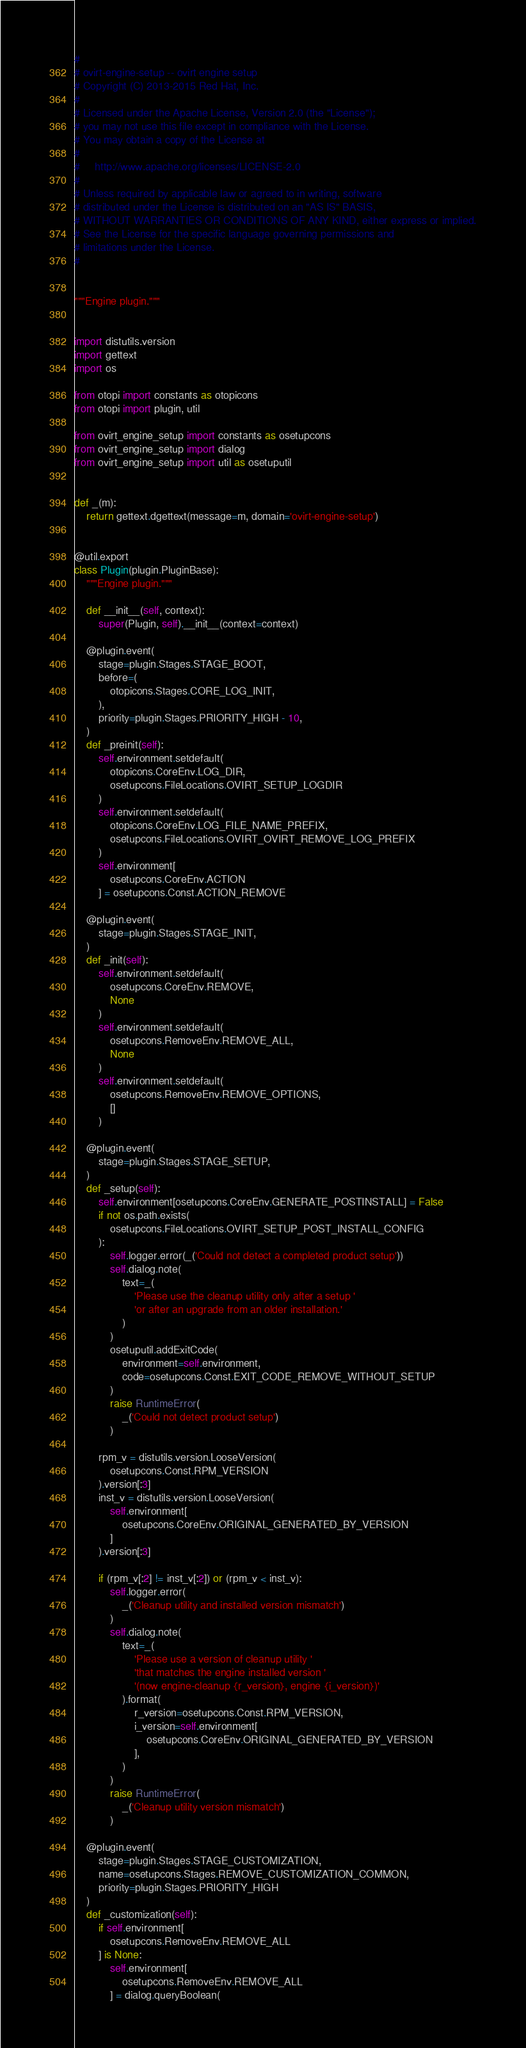Convert code to text. <code><loc_0><loc_0><loc_500><loc_500><_Python_>#
# ovirt-engine-setup -- ovirt engine setup
# Copyright (C) 2013-2015 Red Hat, Inc.
#
# Licensed under the Apache License, Version 2.0 (the "License");
# you may not use this file except in compliance with the License.
# You may obtain a copy of the License at
#
#     http://www.apache.org/licenses/LICENSE-2.0
#
# Unless required by applicable law or agreed to in writing, software
# distributed under the License is distributed on an "AS IS" BASIS,
# WITHOUT WARRANTIES OR CONDITIONS OF ANY KIND, either express or implied.
# See the License for the specific language governing permissions and
# limitations under the License.
#


"""Engine plugin."""


import distutils.version
import gettext
import os

from otopi import constants as otopicons
from otopi import plugin, util

from ovirt_engine_setup import constants as osetupcons
from ovirt_engine_setup import dialog
from ovirt_engine_setup import util as osetuputil


def _(m):
    return gettext.dgettext(message=m, domain='ovirt-engine-setup')


@util.export
class Plugin(plugin.PluginBase):
    """Engine plugin."""

    def __init__(self, context):
        super(Plugin, self).__init__(context=context)

    @plugin.event(
        stage=plugin.Stages.STAGE_BOOT,
        before=(
            otopicons.Stages.CORE_LOG_INIT,
        ),
        priority=plugin.Stages.PRIORITY_HIGH - 10,
    )
    def _preinit(self):
        self.environment.setdefault(
            otopicons.CoreEnv.LOG_DIR,
            osetupcons.FileLocations.OVIRT_SETUP_LOGDIR
        )
        self.environment.setdefault(
            otopicons.CoreEnv.LOG_FILE_NAME_PREFIX,
            osetupcons.FileLocations.OVIRT_OVIRT_REMOVE_LOG_PREFIX
        )
        self.environment[
            osetupcons.CoreEnv.ACTION
        ] = osetupcons.Const.ACTION_REMOVE

    @plugin.event(
        stage=plugin.Stages.STAGE_INIT,
    )
    def _init(self):
        self.environment.setdefault(
            osetupcons.CoreEnv.REMOVE,
            None
        )
        self.environment.setdefault(
            osetupcons.RemoveEnv.REMOVE_ALL,
            None
        )
        self.environment.setdefault(
            osetupcons.RemoveEnv.REMOVE_OPTIONS,
            []
        )

    @plugin.event(
        stage=plugin.Stages.STAGE_SETUP,
    )
    def _setup(self):
        self.environment[osetupcons.CoreEnv.GENERATE_POSTINSTALL] = False
        if not os.path.exists(
            osetupcons.FileLocations.OVIRT_SETUP_POST_INSTALL_CONFIG
        ):
            self.logger.error(_('Could not detect a completed product setup'))
            self.dialog.note(
                text=_(
                    'Please use the cleanup utility only after a setup '
                    'or after an upgrade from an older installation.'
                )
            )
            osetuputil.addExitCode(
                environment=self.environment,
                code=osetupcons.Const.EXIT_CODE_REMOVE_WITHOUT_SETUP
            )
            raise RuntimeError(
                _('Could not detect product setup')
            )

        rpm_v = distutils.version.LooseVersion(
            osetupcons.Const.RPM_VERSION
        ).version[:3]
        inst_v = distutils.version.LooseVersion(
            self.environment[
                osetupcons.CoreEnv.ORIGINAL_GENERATED_BY_VERSION
            ]
        ).version[:3]

        if (rpm_v[:2] != inst_v[:2]) or (rpm_v < inst_v):
            self.logger.error(
                _('Cleanup utility and installed version mismatch')
            )
            self.dialog.note(
                text=_(
                    'Please use a version of cleanup utility '
                    'that matches the engine installed version '
                    '(now engine-cleanup {r_version}, engine {i_version})'
                ).format(
                    r_version=osetupcons.Const.RPM_VERSION,
                    i_version=self.environment[
                        osetupcons.CoreEnv.ORIGINAL_GENERATED_BY_VERSION
                    ],
                )
            )
            raise RuntimeError(
                _('Cleanup utility version mismatch')
            )

    @plugin.event(
        stage=plugin.Stages.STAGE_CUSTOMIZATION,
        name=osetupcons.Stages.REMOVE_CUSTOMIZATION_COMMON,
        priority=plugin.Stages.PRIORITY_HIGH
    )
    def _customization(self):
        if self.environment[
            osetupcons.RemoveEnv.REMOVE_ALL
        ] is None:
            self.environment[
                osetupcons.RemoveEnv.REMOVE_ALL
            ] = dialog.queryBoolean(</code> 